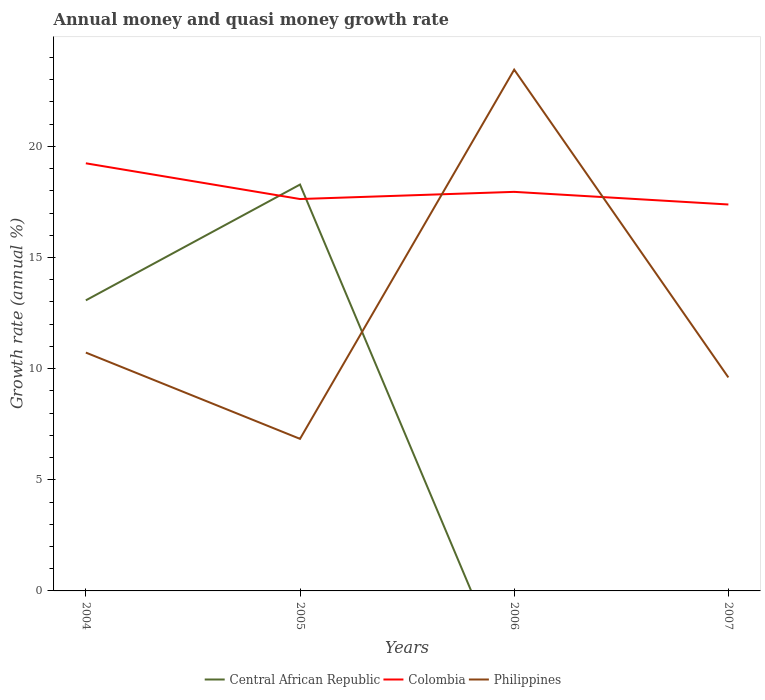How many different coloured lines are there?
Ensure brevity in your answer.  3. Does the line corresponding to Colombia intersect with the line corresponding to Philippines?
Offer a very short reply. Yes. Across all years, what is the maximum growth rate in Philippines?
Provide a short and direct response. 6.84. What is the total growth rate in Philippines in the graph?
Provide a short and direct response. 13.85. What is the difference between the highest and the second highest growth rate in Philippines?
Your answer should be compact. 16.61. What is the difference between the highest and the lowest growth rate in Central African Republic?
Give a very brief answer. 2. What is the difference between two consecutive major ticks on the Y-axis?
Make the answer very short. 5. Does the graph contain grids?
Make the answer very short. No. How many legend labels are there?
Give a very brief answer. 3. What is the title of the graph?
Give a very brief answer. Annual money and quasi money growth rate. Does "Burundi" appear as one of the legend labels in the graph?
Provide a short and direct response. No. What is the label or title of the Y-axis?
Ensure brevity in your answer.  Growth rate (annual %). What is the Growth rate (annual %) in Central African Republic in 2004?
Offer a terse response. 13.07. What is the Growth rate (annual %) of Colombia in 2004?
Provide a short and direct response. 19.24. What is the Growth rate (annual %) in Philippines in 2004?
Keep it short and to the point. 10.72. What is the Growth rate (annual %) in Central African Republic in 2005?
Ensure brevity in your answer.  18.28. What is the Growth rate (annual %) in Colombia in 2005?
Keep it short and to the point. 17.63. What is the Growth rate (annual %) of Philippines in 2005?
Ensure brevity in your answer.  6.84. What is the Growth rate (annual %) of Central African Republic in 2006?
Make the answer very short. 0. What is the Growth rate (annual %) of Colombia in 2006?
Provide a short and direct response. 17.95. What is the Growth rate (annual %) of Philippines in 2006?
Offer a very short reply. 23.45. What is the Growth rate (annual %) of Colombia in 2007?
Make the answer very short. 17.39. What is the Growth rate (annual %) in Philippines in 2007?
Your answer should be very brief. 9.61. Across all years, what is the maximum Growth rate (annual %) in Central African Republic?
Your answer should be compact. 18.28. Across all years, what is the maximum Growth rate (annual %) in Colombia?
Give a very brief answer. 19.24. Across all years, what is the maximum Growth rate (annual %) of Philippines?
Offer a terse response. 23.45. Across all years, what is the minimum Growth rate (annual %) in Central African Republic?
Your answer should be very brief. 0. Across all years, what is the minimum Growth rate (annual %) in Colombia?
Give a very brief answer. 17.39. Across all years, what is the minimum Growth rate (annual %) of Philippines?
Give a very brief answer. 6.84. What is the total Growth rate (annual %) of Central African Republic in the graph?
Make the answer very short. 31.36. What is the total Growth rate (annual %) of Colombia in the graph?
Your answer should be very brief. 72.21. What is the total Growth rate (annual %) in Philippines in the graph?
Ensure brevity in your answer.  50.62. What is the difference between the Growth rate (annual %) of Central African Republic in 2004 and that in 2005?
Your response must be concise. -5.21. What is the difference between the Growth rate (annual %) in Colombia in 2004 and that in 2005?
Provide a succinct answer. 1.61. What is the difference between the Growth rate (annual %) of Philippines in 2004 and that in 2005?
Ensure brevity in your answer.  3.88. What is the difference between the Growth rate (annual %) in Colombia in 2004 and that in 2006?
Your answer should be very brief. 1.29. What is the difference between the Growth rate (annual %) in Philippines in 2004 and that in 2006?
Your answer should be compact. -12.73. What is the difference between the Growth rate (annual %) in Colombia in 2004 and that in 2007?
Offer a terse response. 1.85. What is the difference between the Growth rate (annual %) in Philippines in 2004 and that in 2007?
Your answer should be very brief. 1.12. What is the difference between the Growth rate (annual %) of Colombia in 2005 and that in 2006?
Provide a short and direct response. -0.32. What is the difference between the Growth rate (annual %) of Philippines in 2005 and that in 2006?
Offer a terse response. -16.61. What is the difference between the Growth rate (annual %) of Colombia in 2005 and that in 2007?
Keep it short and to the point. 0.25. What is the difference between the Growth rate (annual %) of Philippines in 2005 and that in 2007?
Offer a very short reply. -2.76. What is the difference between the Growth rate (annual %) of Colombia in 2006 and that in 2007?
Your answer should be very brief. 0.57. What is the difference between the Growth rate (annual %) of Philippines in 2006 and that in 2007?
Keep it short and to the point. 13.85. What is the difference between the Growth rate (annual %) in Central African Republic in 2004 and the Growth rate (annual %) in Colombia in 2005?
Offer a terse response. -4.56. What is the difference between the Growth rate (annual %) of Central African Republic in 2004 and the Growth rate (annual %) of Philippines in 2005?
Offer a very short reply. 6.23. What is the difference between the Growth rate (annual %) in Colombia in 2004 and the Growth rate (annual %) in Philippines in 2005?
Provide a short and direct response. 12.4. What is the difference between the Growth rate (annual %) of Central African Republic in 2004 and the Growth rate (annual %) of Colombia in 2006?
Your response must be concise. -4.88. What is the difference between the Growth rate (annual %) in Central African Republic in 2004 and the Growth rate (annual %) in Philippines in 2006?
Provide a short and direct response. -10.38. What is the difference between the Growth rate (annual %) in Colombia in 2004 and the Growth rate (annual %) in Philippines in 2006?
Offer a very short reply. -4.21. What is the difference between the Growth rate (annual %) in Central African Republic in 2004 and the Growth rate (annual %) in Colombia in 2007?
Provide a short and direct response. -4.31. What is the difference between the Growth rate (annual %) of Central African Republic in 2004 and the Growth rate (annual %) of Philippines in 2007?
Your answer should be very brief. 3.47. What is the difference between the Growth rate (annual %) of Colombia in 2004 and the Growth rate (annual %) of Philippines in 2007?
Provide a succinct answer. 9.63. What is the difference between the Growth rate (annual %) of Central African Republic in 2005 and the Growth rate (annual %) of Colombia in 2006?
Keep it short and to the point. 0.33. What is the difference between the Growth rate (annual %) of Central African Republic in 2005 and the Growth rate (annual %) of Philippines in 2006?
Provide a succinct answer. -5.17. What is the difference between the Growth rate (annual %) in Colombia in 2005 and the Growth rate (annual %) in Philippines in 2006?
Offer a terse response. -5.82. What is the difference between the Growth rate (annual %) of Central African Republic in 2005 and the Growth rate (annual %) of Colombia in 2007?
Ensure brevity in your answer.  0.9. What is the difference between the Growth rate (annual %) in Central African Republic in 2005 and the Growth rate (annual %) in Philippines in 2007?
Your answer should be very brief. 8.68. What is the difference between the Growth rate (annual %) in Colombia in 2005 and the Growth rate (annual %) in Philippines in 2007?
Provide a short and direct response. 8.03. What is the difference between the Growth rate (annual %) in Colombia in 2006 and the Growth rate (annual %) in Philippines in 2007?
Your answer should be very brief. 8.35. What is the average Growth rate (annual %) of Central African Republic per year?
Your response must be concise. 7.84. What is the average Growth rate (annual %) in Colombia per year?
Provide a succinct answer. 18.05. What is the average Growth rate (annual %) in Philippines per year?
Keep it short and to the point. 12.66. In the year 2004, what is the difference between the Growth rate (annual %) of Central African Republic and Growth rate (annual %) of Colombia?
Your answer should be compact. -6.17. In the year 2004, what is the difference between the Growth rate (annual %) of Central African Republic and Growth rate (annual %) of Philippines?
Keep it short and to the point. 2.35. In the year 2004, what is the difference between the Growth rate (annual %) of Colombia and Growth rate (annual %) of Philippines?
Provide a succinct answer. 8.52. In the year 2005, what is the difference between the Growth rate (annual %) of Central African Republic and Growth rate (annual %) of Colombia?
Provide a succinct answer. 0.65. In the year 2005, what is the difference between the Growth rate (annual %) of Central African Republic and Growth rate (annual %) of Philippines?
Provide a short and direct response. 11.44. In the year 2005, what is the difference between the Growth rate (annual %) in Colombia and Growth rate (annual %) in Philippines?
Offer a terse response. 10.79. In the year 2006, what is the difference between the Growth rate (annual %) in Colombia and Growth rate (annual %) in Philippines?
Give a very brief answer. -5.5. In the year 2007, what is the difference between the Growth rate (annual %) in Colombia and Growth rate (annual %) in Philippines?
Make the answer very short. 7.78. What is the ratio of the Growth rate (annual %) of Central African Republic in 2004 to that in 2005?
Your response must be concise. 0.72. What is the ratio of the Growth rate (annual %) of Colombia in 2004 to that in 2005?
Ensure brevity in your answer.  1.09. What is the ratio of the Growth rate (annual %) of Philippines in 2004 to that in 2005?
Ensure brevity in your answer.  1.57. What is the ratio of the Growth rate (annual %) in Colombia in 2004 to that in 2006?
Give a very brief answer. 1.07. What is the ratio of the Growth rate (annual %) of Philippines in 2004 to that in 2006?
Your response must be concise. 0.46. What is the ratio of the Growth rate (annual %) in Colombia in 2004 to that in 2007?
Make the answer very short. 1.11. What is the ratio of the Growth rate (annual %) in Philippines in 2004 to that in 2007?
Make the answer very short. 1.12. What is the ratio of the Growth rate (annual %) in Philippines in 2005 to that in 2006?
Your answer should be compact. 0.29. What is the ratio of the Growth rate (annual %) in Colombia in 2005 to that in 2007?
Offer a terse response. 1.01. What is the ratio of the Growth rate (annual %) in Philippines in 2005 to that in 2007?
Your response must be concise. 0.71. What is the ratio of the Growth rate (annual %) of Colombia in 2006 to that in 2007?
Provide a succinct answer. 1.03. What is the ratio of the Growth rate (annual %) of Philippines in 2006 to that in 2007?
Give a very brief answer. 2.44. What is the difference between the highest and the second highest Growth rate (annual %) in Colombia?
Your response must be concise. 1.29. What is the difference between the highest and the second highest Growth rate (annual %) of Philippines?
Keep it short and to the point. 12.73. What is the difference between the highest and the lowest Growth rate (annual %) of Central African Republic?
Your answer should be very brief. 18.28. What is the difference between the highest and the lowest Growth rate (annual %) of Colombia?
Your answer should be compact. 1.85. What is the difference between the highest and the lowest Growth rate (annual %) of Philippines?
Keep it short and to the point. 16.61. 